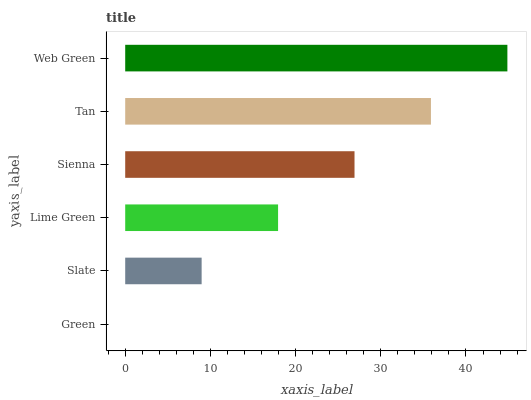Is Green the minimum?
Answer yes or no. Yes. Is Web Green the maximum?
Answer yes or no. Yes. Is Slate the minimum?
Answer yes or no. No. Is Slate the maximum?
Answer yes or no. No. Is Slate greater than Green?
Answer yes or no. Yes. Is Green less than Slate?
Answer yes or no. Yes. Is Green greater than Slate?
Answer yes or no. No. Is Slate less than Green?
Answer yes or no. No. Is Sienna the high median?
Answer yes or no. Yes. Is Lime Green the low median?
Answer yes or no. Yes. Is Green the high median?
Answer yes or no. No. Is Slate the low median?
Answer yes or no. No. 